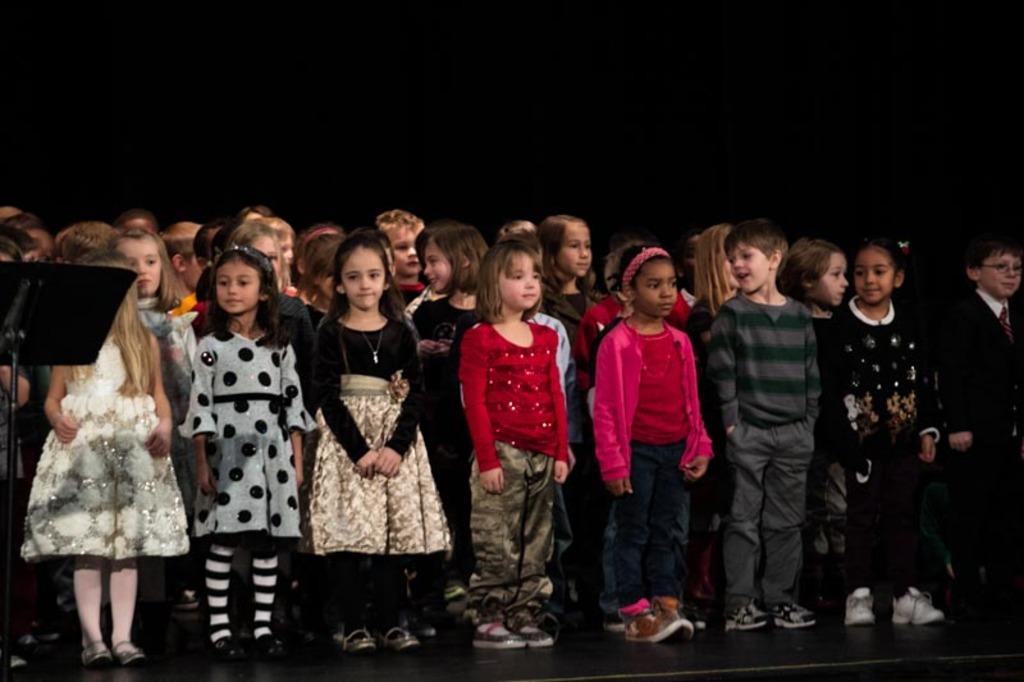What are the children doing on the stage? The children are standing on the stage. What can be seen on the left side of the stage? There is a metal stand on the left side of the stage. What color is the background of the image? The background of the image is in black color. How much dirt is visible on the stage in the image? There is no dirt visible on the stage in the image. What type of toad can be seen hopping on the stage in the image? There are no toads present in the image; it features children standing on the stage. 